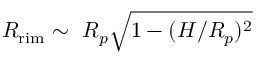<formula> <loc_0><loc_0><loc_500><loc_500>R _ { r i m } \sim R _ { p } \sqrt { 1 - ( H / R _ { p } ) ^ { 2 } }</formula> 